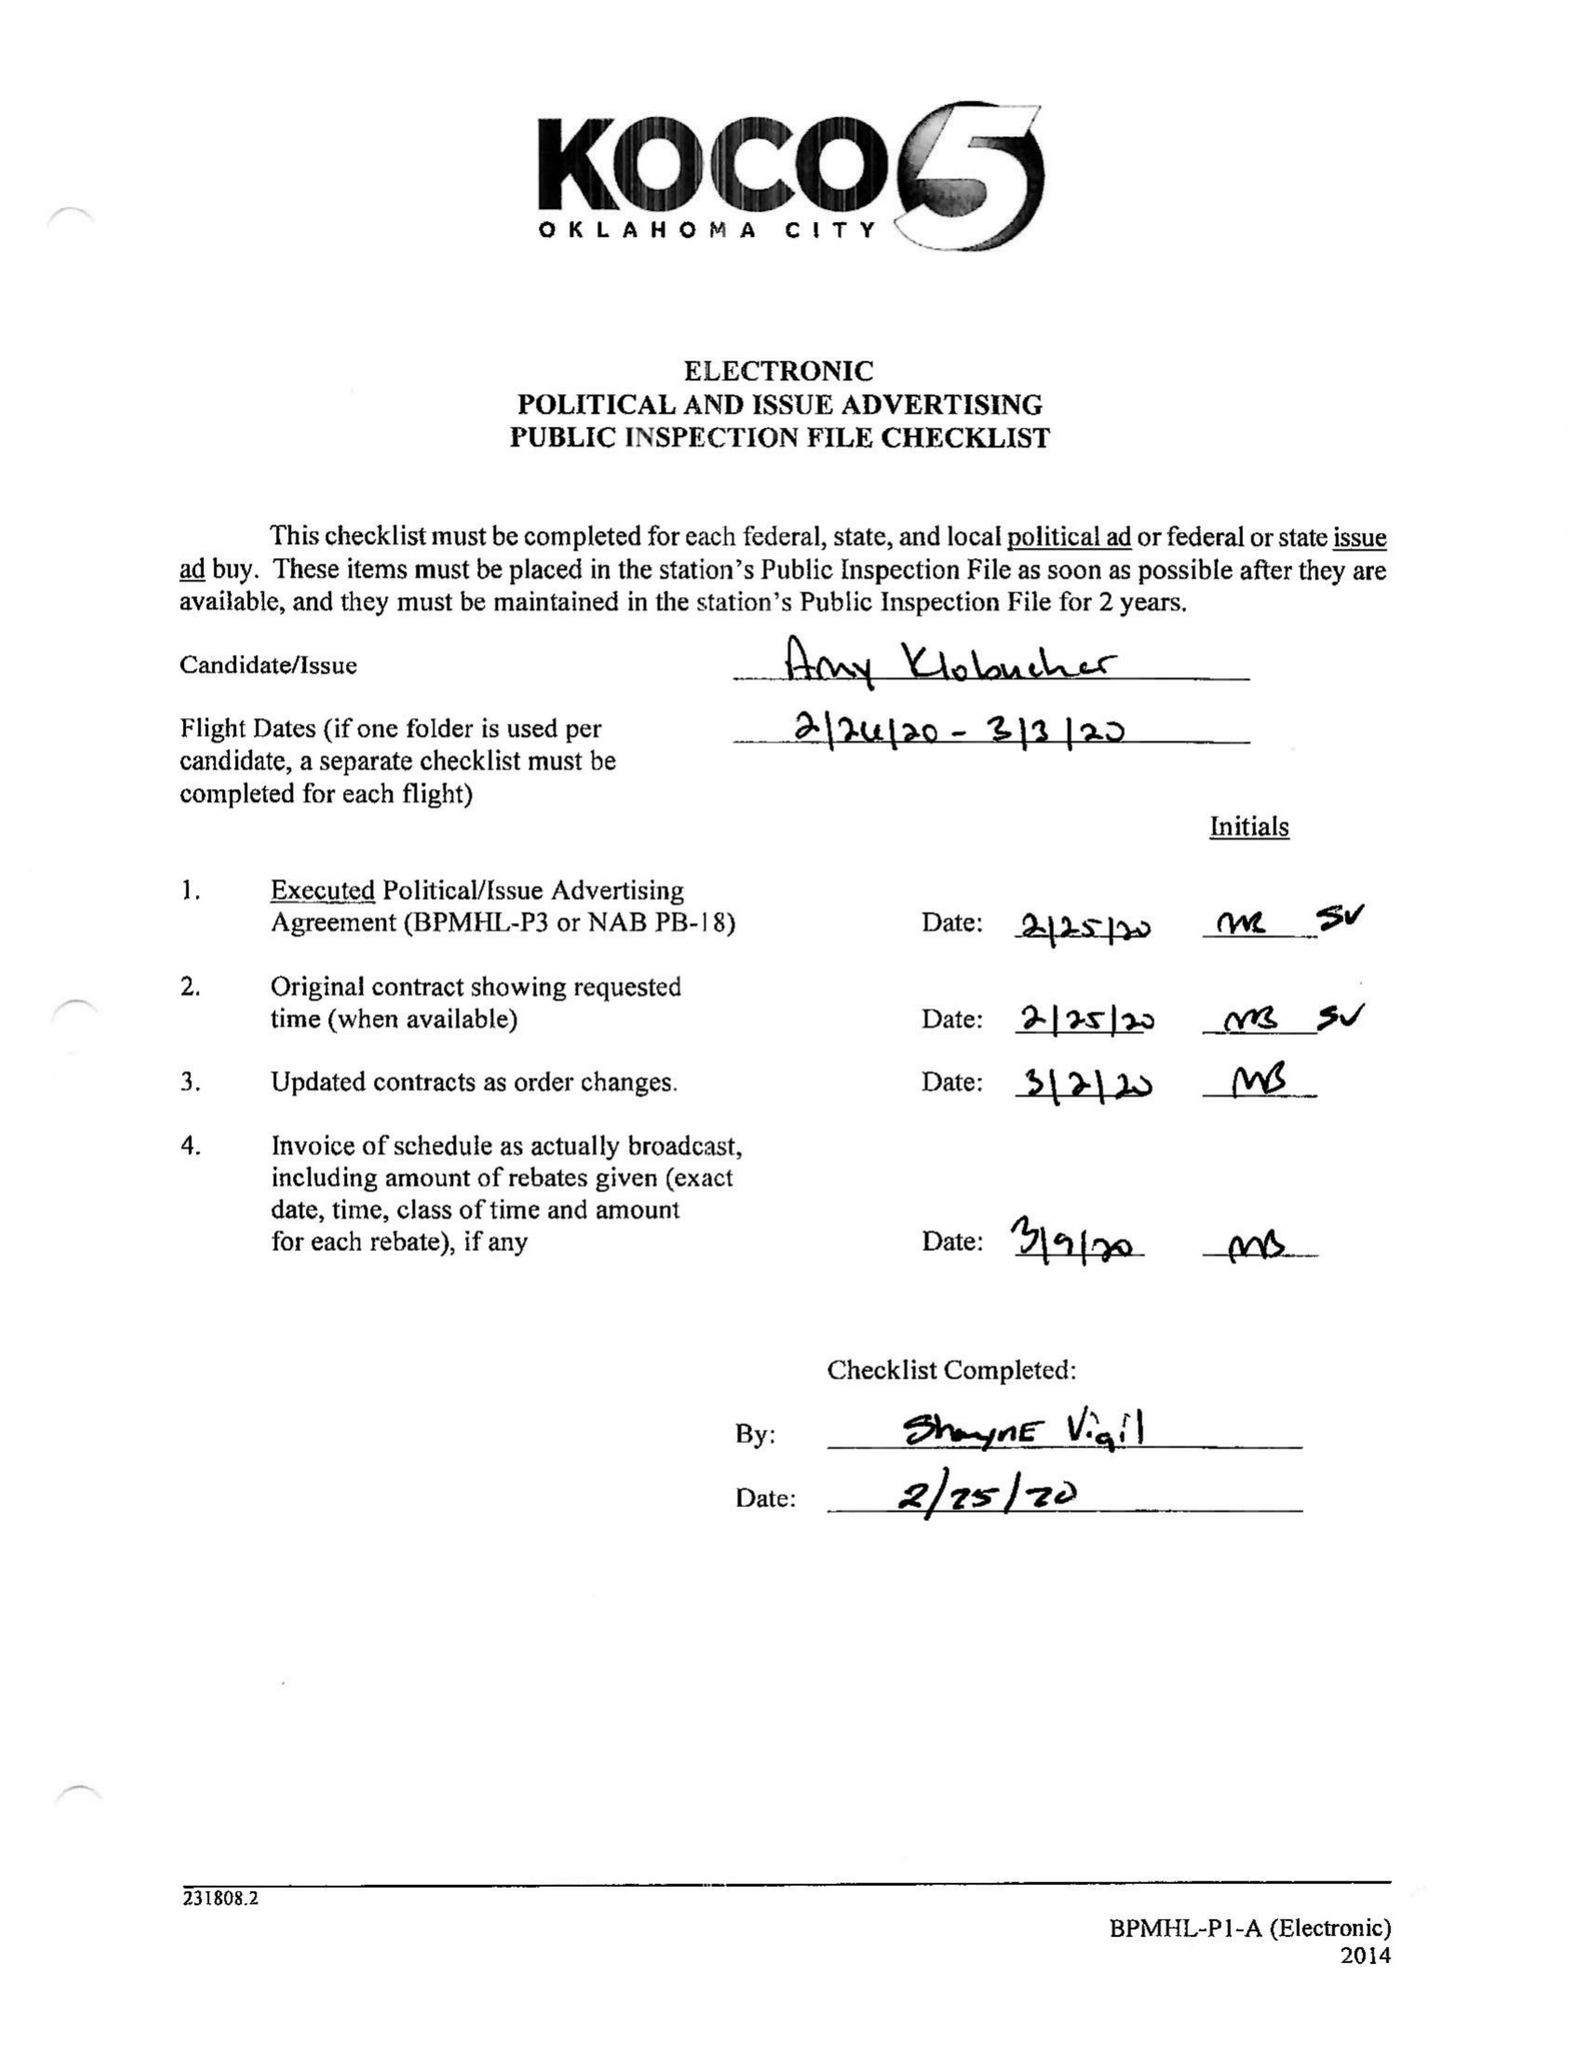What is the value for the gross_amount?
Answer the question using a single word or phrase. 13035.00 